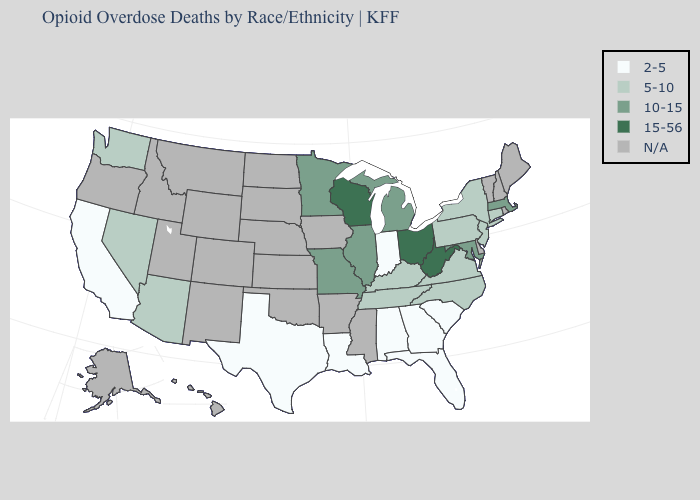Does the first symbol in the legend represent the smallest category?
Write a very short answer. Yes. What is the value of Wisconsin?
Concise answer only. 15-56. Name the states that have a value in the range 5-10?
Answer briefly. Arizona, Connecticut, Kentucky, Nevada, New Jersey, New York, North Carolina, Pennsylvania, Tennessee, Virginia, Washington. What is the lowest value in states that border Mississippi?
Give a very brief answer. 2-5. Among the states that border Texas , which have the lowest value?
Short answer required. Louisiana. Which states hav the highest value in the South?
Write a very short answer. West Virginia. Among the states that border Iowa , which have the lowest value?
Be succinct. Illinois, Minnesota, Missouri. Does Pennsylvania have the highest value in the USA?
Give a very brief answer. No. Name the states that have a value in the range 5-10?
Give a very brief answer. Arizona, Connecticut, Kentucky, Nevada, New Jersey, New York, North Carolina, Pennsylvania, Tennessee, Virginia, Washington. What is the lowest value in the Northeast?
Quick response, please. 5-10. Name the states that have a value in the range N/A?
Be succinct. Alaska, Arkansas, Colorado, Delaware, Hawaii, Idaho, Iowa, Kansas, Maine, Mississippi, Montana, Nebraska, New Hampshire, New Mexico, North Dakota, Oklahoma, Oregon, Rhode Island, South Dakota, Utah, Vermont, Wyoming. What is the value of Indiana?
Quick response, please. 2-5. Which states hav the highest value in the South?
Concise answer only. West Virginia. 